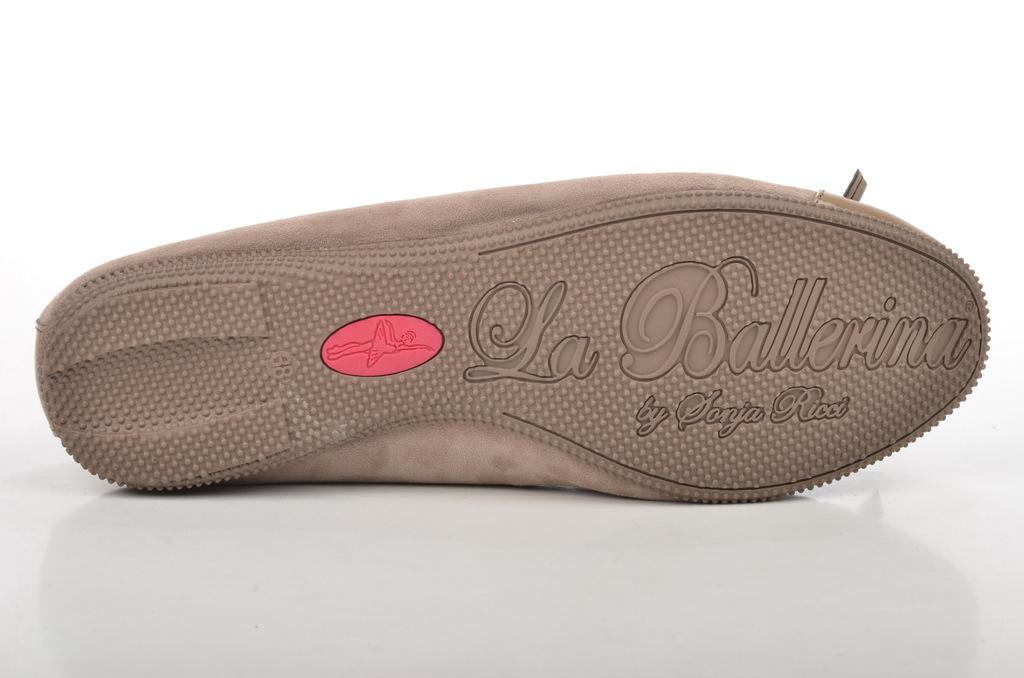Describe this image in one or two sentences. In this picture we can observe a sole of a shoe placed on the white color surface. We can observe some text on the sole. The sole is in brown color. The background is in white color. 